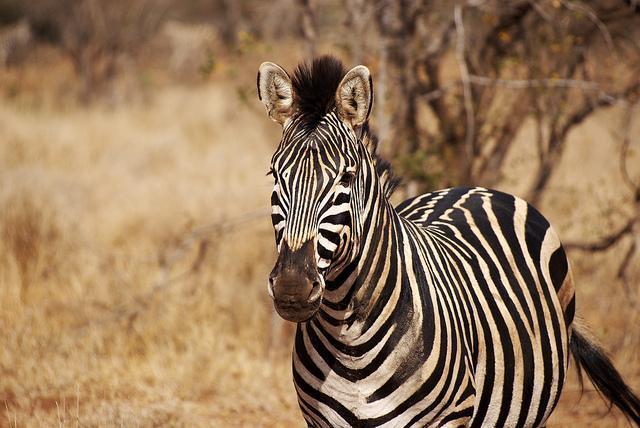How many zebras are there?
Give a very brief answer. 1. How many people (in front and focus of the photo) have no birds on their shoulders?
Give a very brief answer. 0. 